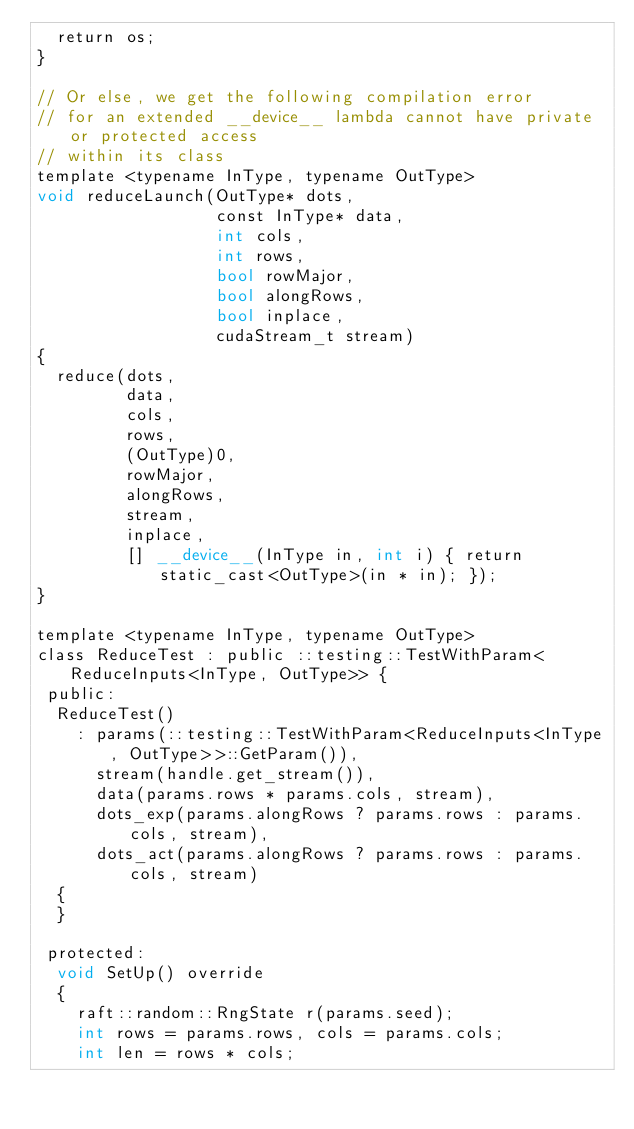<code> <loc_0><loc_0><loc_500><loc_500><_Cuda_>  return os;
}

// Or else, we get the following compilation error
// for an extended __device__ lambda cannot have private or protected access
// within its class
template <typename InType, typename OutType>
void reduceLaunch(OutType* dots,
                  const InType* data,
                  int cols,
                  int rows,
                  bool rowMajor,
                  bool alongRows,
                  bool inplace,
                  cudaStream_t stream)
{
  reduce(dots,
         data,
         cols,
         rows,
         (OutType)0,
         rowMajor,
         alongRows,
         stream,
         inplace,
         [] __device__(InType in, int i) { return static_cast<OutType>(in * in); });
}

template <typename InType, typename OutType>
class ReduceTest : public ::testing::TestWithParam<ReduceInputs<InType, OutType>> {
 public:
  ReduceTest()
    : params(::testing::TestWithParam<ReduceInputs<InType, OutType>>::GetParam()),
      stream(handle.get_stream()),
      data(params.rows * params.cols, stream),
      dots_exp(params.alongRows ? params.rows : params.cols, stream),
      dots_act(params.alongRows ? params.rows : params.cols, stream)
  {
  }

 protected:
  void SetUp() override
  {
    raft::random::RngState r(params.seed);
    int rows = params.rows, cols = params.cols;
    int len = rows * cols;</code> 